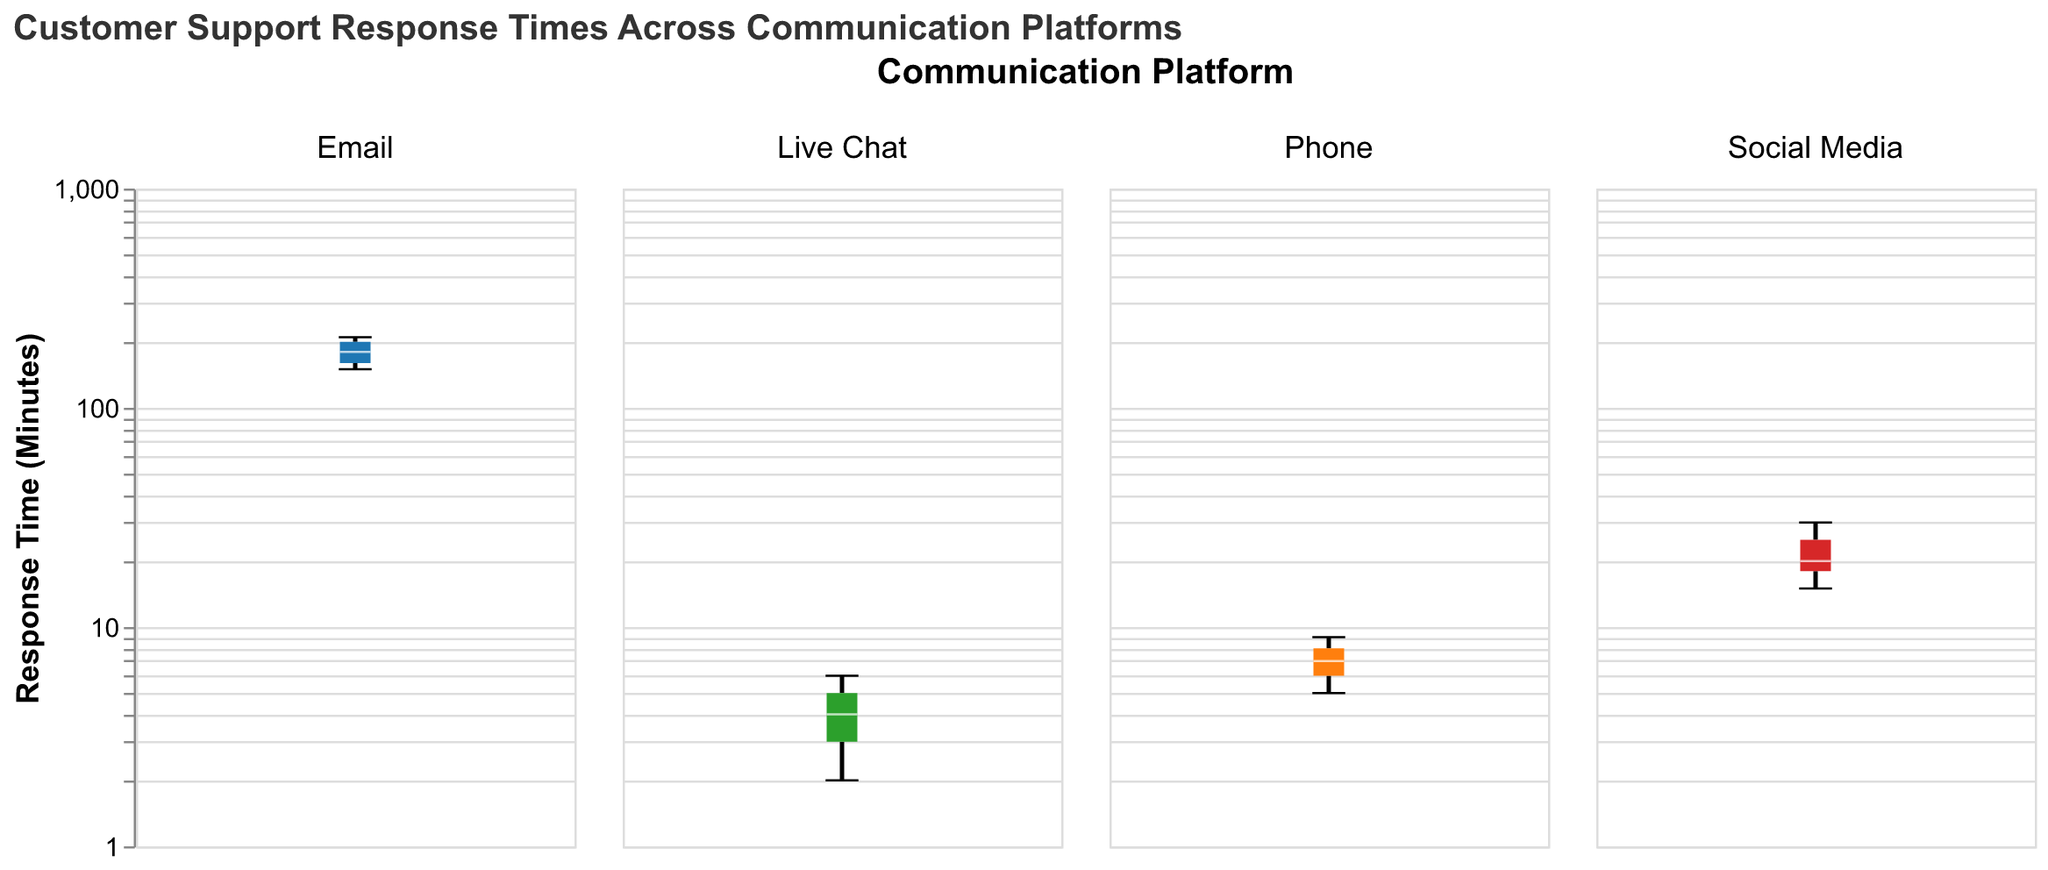What is the median response time for the Email platform? The box plot for the Email platform shows the median response time as a horizontal line across the box. The median response time for Email is approximately 180 minutes.
Answer: 180 minutes Which platform has the lowest minimum response time? By looking at the whiskers extending from the boxes of each platform, the lowest minimum response time can be observed. The Live Chat platform has a minimum response time of 2 minutes, which is the lowest among all platforms.
Answer: Live Chat Which platform has the highest maximum response time? By observing the top whisker of each box plot, the Social Media platform has the highest maximum response time of 30 minutes.
Answer: Social Media Compare the median response times of Phone and Live Chat platforms. Which one is faster? The median response time is represented by the line inside the box. For the Phone platform, the median is approximately 7 minutes. For the Live Chat platform, the median is approximately 4 minutes. Therefore, Live Chat has a faster median response time.
Answer: Live Chat What is the interquartile range (IQR) for the Social Media platform? The interquartile range (IQR) is the difference between the upper quartile (Q3) and the lower quartile (Q1). For the Social Media platform: Q3 ≈ 25 minutes and Q1 ≈ 15 minutes. So, IQR = 25 - 15 = 10 minutes.
Answer: 10 minutes How much longer is the maximum response time for Email compared to the median response time for Social Media? The maximum response time for Email is 210 minutes, and the median response time for Social Media is 20 minutes. The difference is 210 - 20 = 190 minutes.
Answer: 190 minutes Which platform shows the smallest range in response times? The range can be observed by the length of the whiskers of the box plots. The Phone platform shows a range of 4 minutes (from 5 to 9 minutes), which is the smallest among all platforms.
Answer: Phone Is there any overlap in the interquartile ranges of Phone and Live Chat platforms? The IQR of Phone is from approximately 6 to 8 minutes, and the IQR of Live Chat is from approximately 3 to 5 minutes. There is no overlap between these ranges.
Answer: No Consider the maximum response times of Phone and Live Chat platforms. By how many minutes does the Phone platform exceed the Live Chat platform? The maximum response time for the Phone platform is 9 minutes, and for the Live Chat platform, it is 6 minutes. The difference is 9 - 6 = 3 minutes.
Answer: 3 minutes 